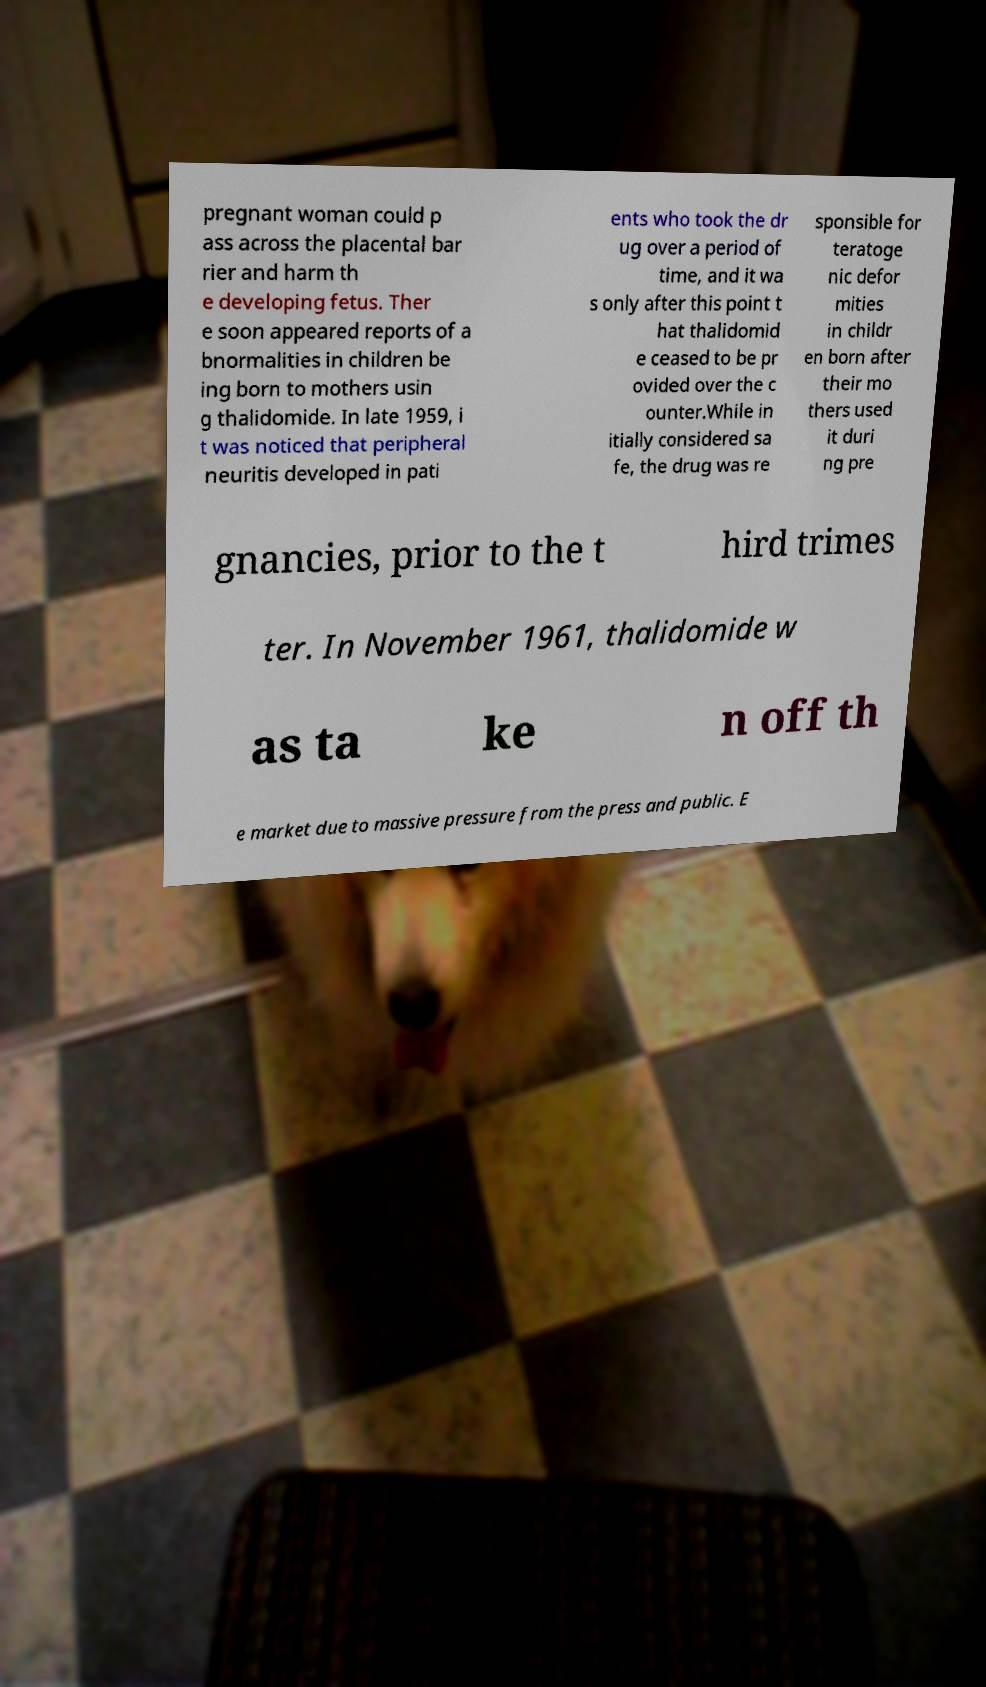What messages or text are displayed in this image? I need them in a readable, typed format. pregnant woman could p ass across the placental bar rier and harm th e developing fetus. Ther e soon appeared reports of a bnormalities in children be ing born to mothers usin g thalidomide. In late 1959, i t was noticed that peripheral neuritis developed in pati ents who took the dr ug over a period of time, and it wa s only after this point t hat thalidomid e ceased to be pr ovided over the c ounter.While in itially considered sa fe, the drug was re sponsible for teratoge nic defor mities in childr en born after their mo thers used it duri ng pre gnancies, prior to the t hird trimes ter. In November 1961, thalidomide w as ta ke n off th e market due to massive pressure from the press and public. E 